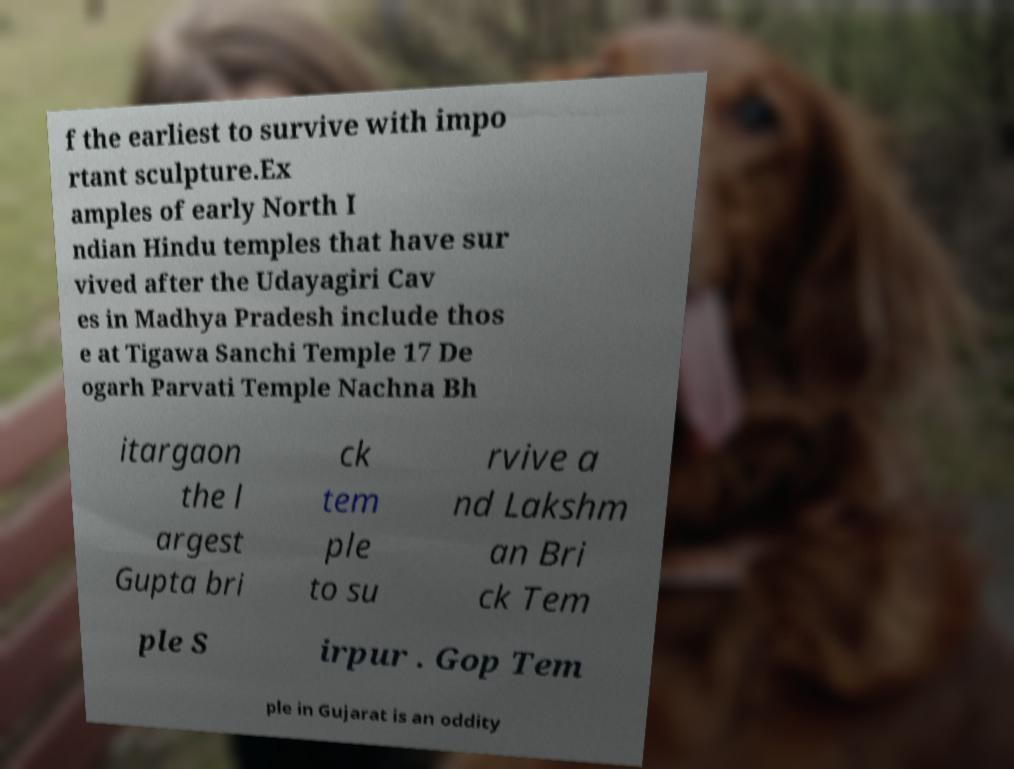Can you accurately transcribe the text from the provided image for me? f the earliest to survive with impo rtant sculpture.Ex amples of early North I ndian Hindu temples that have sur vived after the Udayagiri Cav es in Madhya Pradesh include thos e at Tigawa Sanchi Temple 17 De ogarh Parvati Temple Nachna Bh itargaon the l argest Gupta bri ck tem ple to su rvive a nd Lakshm an Bri ck Tem ple S irpur . Gop Tem ple in Gujarat is an oddity 